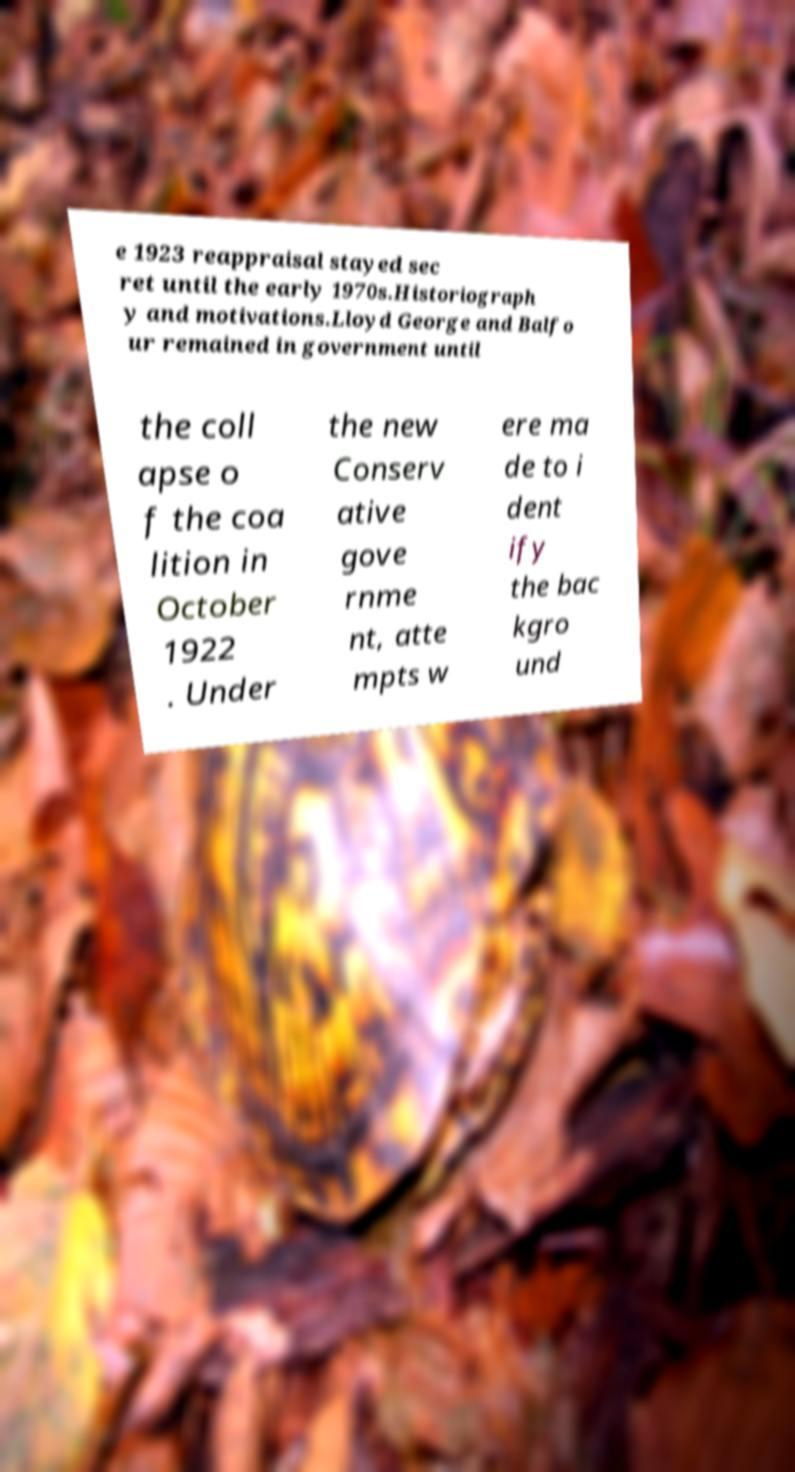Could you assist in decoding the text presented in this image and type it out clearly? e 1923 reappraisal stayed sec ret until the early 1970s.Historiograph y and motivations.Lloyd George and Balfo ur remained in government until the coll apse o f the coa lition in October 1922 . Under the new Conserv ative gove rnme nt, atte mpts w ere ma de to i dent ify the bac kgro und 